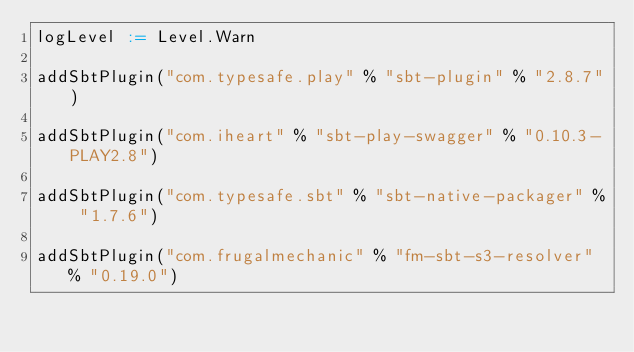<code> <loc_0><loc_0><loc_500><loc_500><_Scala_>logLevel := Level.Warn

addSbtPlugin("com.typesafe.play" % "sbt-plugin" % "2.8.7")

addSbtPlugin("com.iheart" % "sbt-play-swagger" % "0.10.3-PLAY2.8")

addSbtPlugin("com.typesafe.sbt" % "sbt-native-packager" % "1.7.6")

addSbtPlugin("com.frugalmechanic" % "fm-sbt-s3-resolver" % "0.19.0")
</code> 